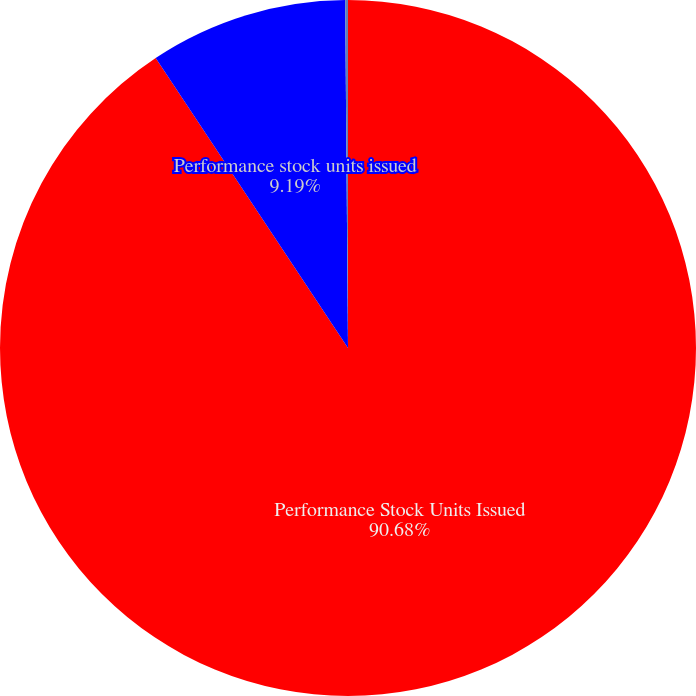Convert chart to OTSL. <chart><loc_0><loc_0><loc_500><loc_500><pie_chart><fcel>Performance Stock Units Issued<fcel>Performance stock units issued<fcel>Expected life in years<nl><fcel>90.68%<fcel>9.19%<fcel>0.13%<nl></chart> 